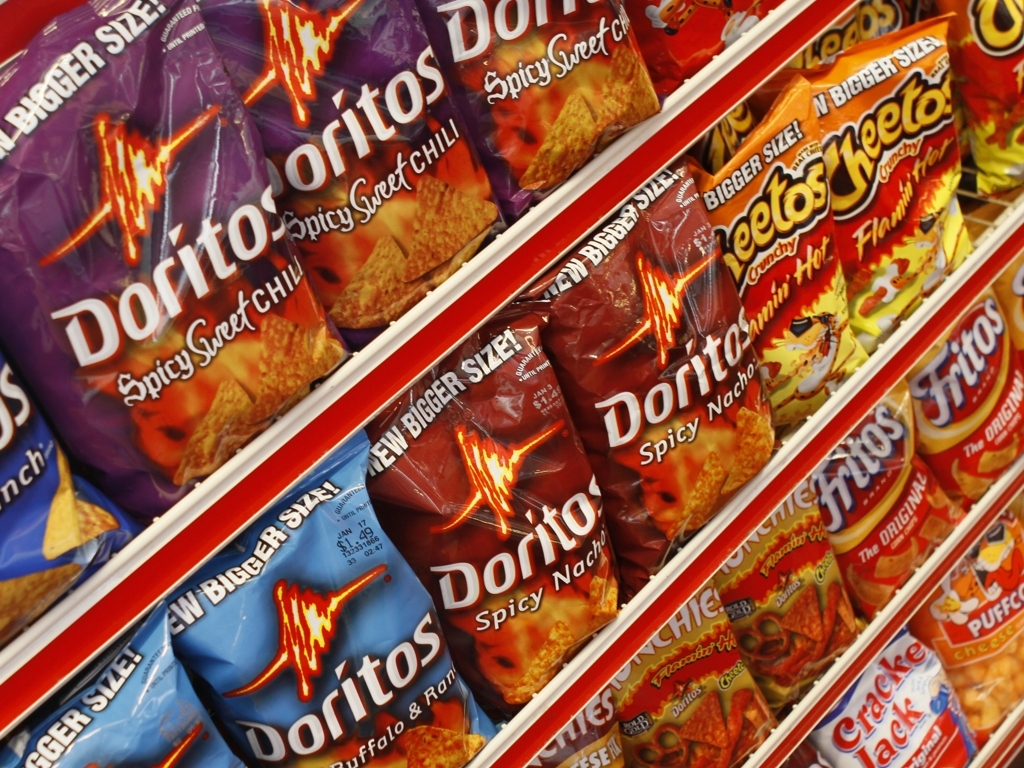Are these products marketed towards a particular type of consumer? While the marketing of these products doesn’t target a specific demographic explicitly, the bold typography and intense imagery of flames suggest they are aimed at consumers looking for bold flavors and perhaps skew towards a younger audience that enjoys adventurous snacking. 